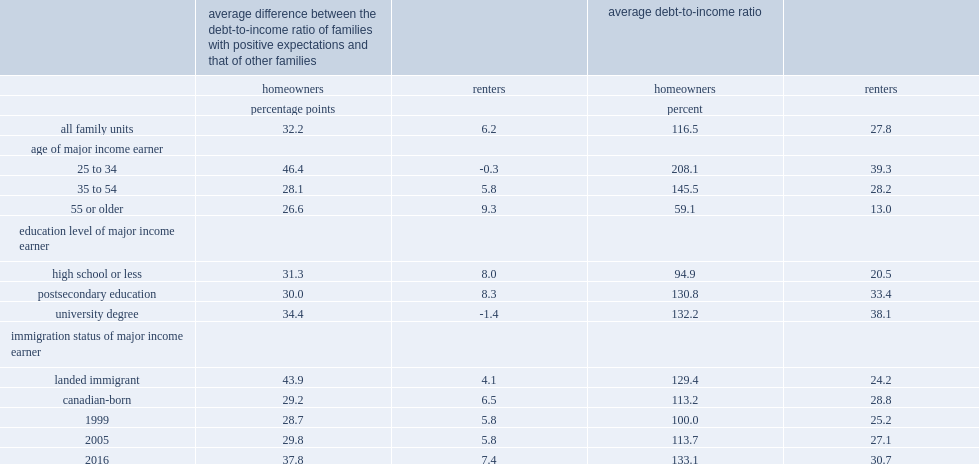How many pertange points were the debt-to-income ratios of homeowner families with positive expectations higher than the debt-to-income ratios of other comparable families? 32.2. What is the average debt-to-income ratio observed for the sample of homeowners? 116.5. 